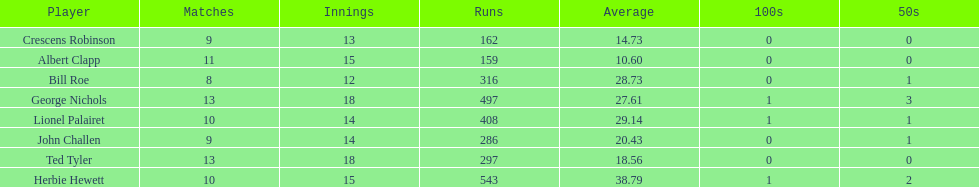How many players played more than 10 matches? 3. 